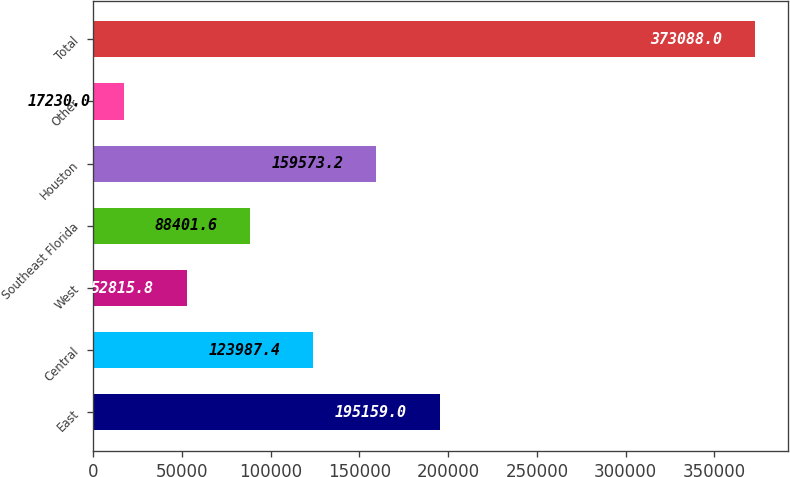Convert chart to OTSL. <chart><loc_0><loc_0><loc_500><loc_500><bar_chart><fcel>East<fcel>Central<fcel>West<fcel>Southeast Florida<fcel>Houston<fcel>Other<fcel>Total<nl><fcel>195159<fcel>123987<fcel>52815.8<fcel>88401.6<fcel>159573<fcel>17230<fcel>373088<nl></chart> 